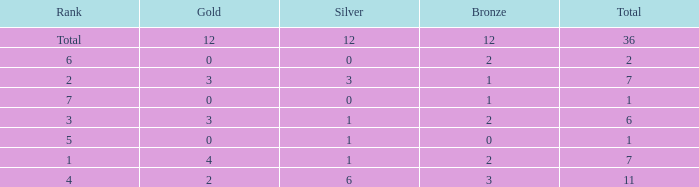Give me the full table as a dictionary. {'header': ['Rank', 'Gold', 'Silver', 'Bronze', 'Total'], 'rows': [['Total', '12', '12', '12', '36'], ['6', '0', '0', '2', '2'], ['2', '3', '3', '1', '7'], ['7', '0', '0', '1', '1'], ['3', '3', '1', '2', '6'], ['5', '0', '1', '0', '1'], ['1', '4', '1', '2', '7'], ['4', '2', '6', '3', '11']]} What is the number of bronze medals when there are fewer than 0 silver medals? None. 